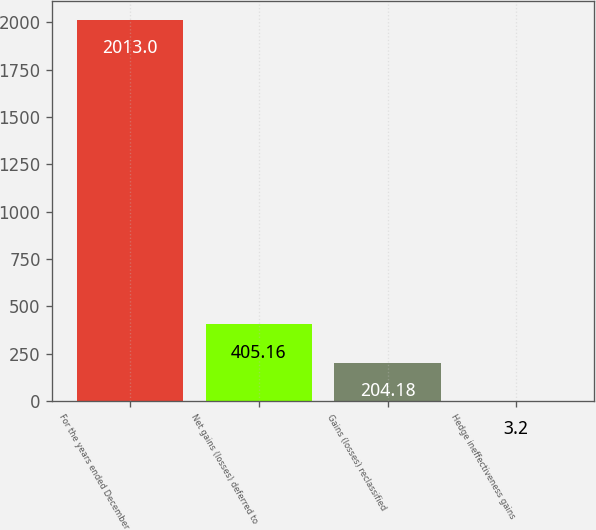Convert chart to OTSL. <chart><loc_0><loc_0><loc_500><loc_500><bar_chart><fcel>For the years ended December<fcel>Net gains (losses) deferred to<fcel>Gains (losses) reclassified<fcel>Hedge ineffectiveness gains<nl><fcel>2013<fcel>405.16<fcel>204.18<fcel>3.2<nl></chart> 